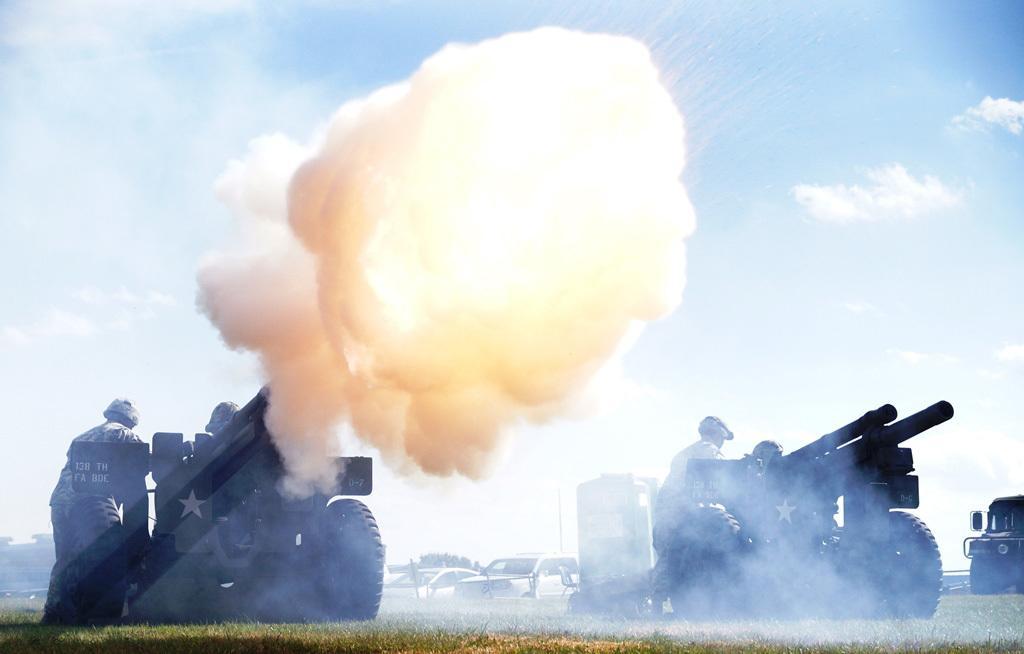Could you give a brief overview of what you see in this image? In this image there are few army vehicles having weapons on it. Few persons are standing behind the vehicles. Behind it there are few vehicles on the grassland. Top of image there is sky with some clouds. 